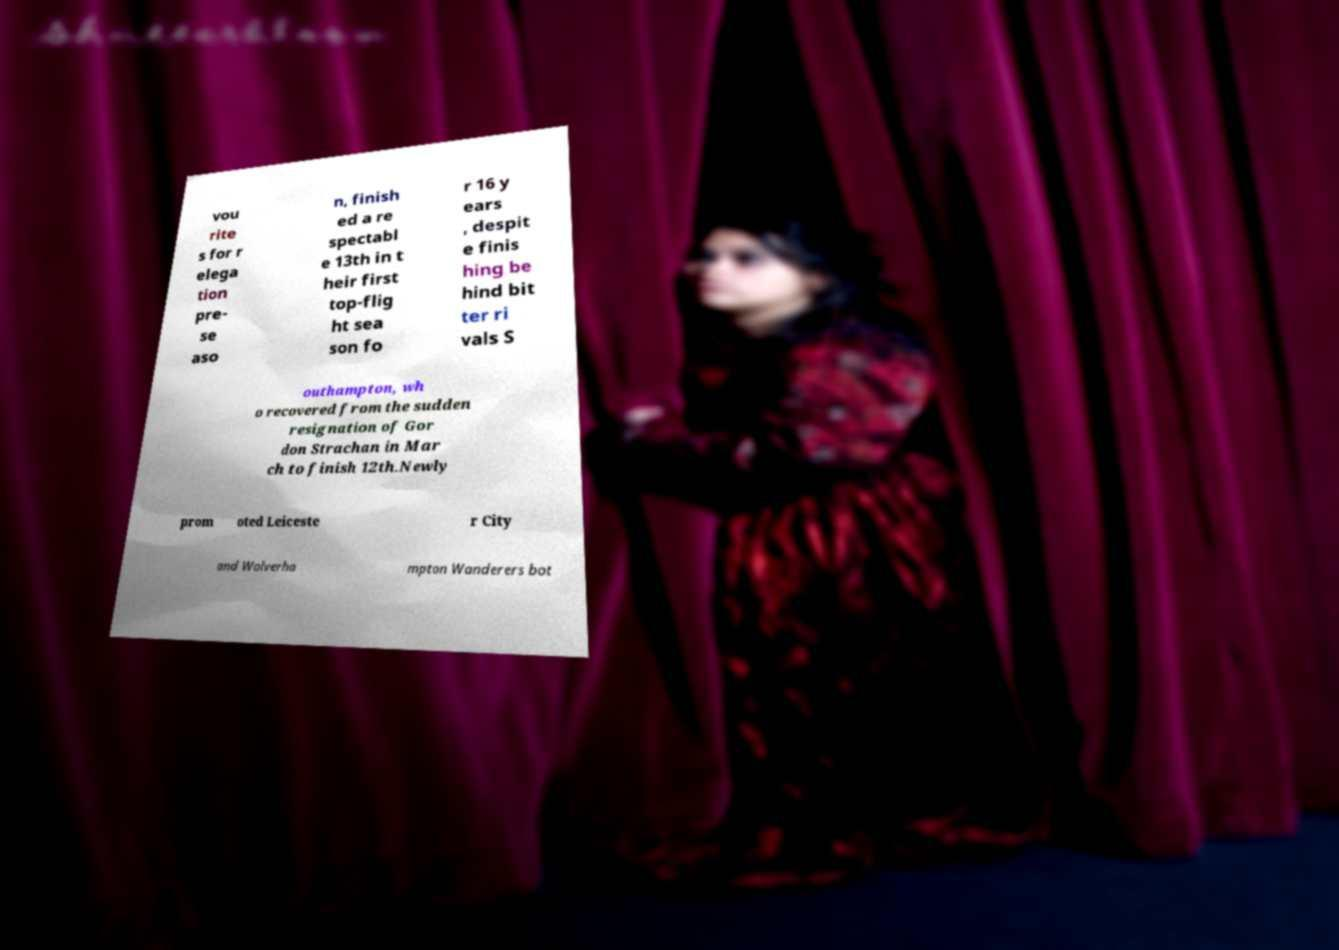Can you read and provide the text displayed in the image?This photo seems to have some interesting text. Can you extract and type it out for me? vou rite s for r elega tion pre- se aso n, finish ed a re spectabl e 13th in t heir first top-flig ht sea son fo r 16 y ears , despit e finis hing be hind bit ter ri vals S outhampton, wh o recovered from the sudden resignation of Gor don Strachan in Mar ch to finish 12th.Newly prom oted Leiceste r City and Wolverha mpton Wanderers bot 